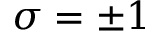Convert formula to latex. <formula><loc_0><loc_0><loc_500><loc_500>\sigma = \pm 1</formula> 